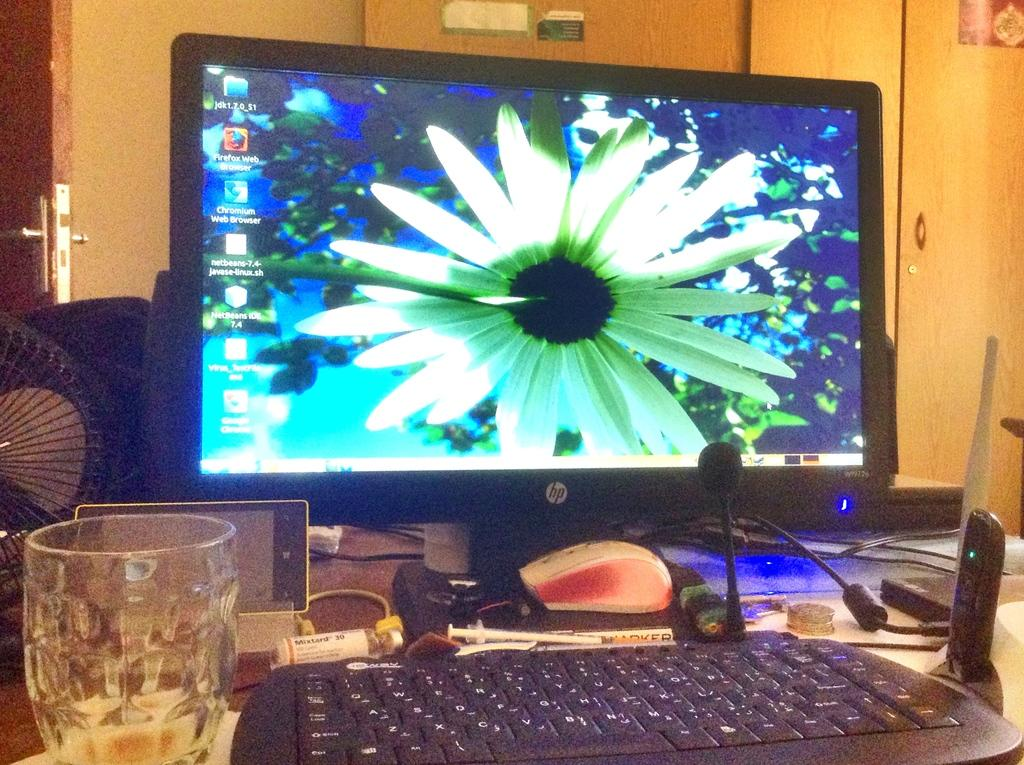What electronic device is on the table in the image? There is a computer on the table in the image. What type of container is on the table? There is a glass on the table. Can you identify any other objects in the image? Yes, there is a fan in the image. What type of gate is visible in the image? There is no gate present in the image. How much tax is being paid for the computer in the image? There is no information about taxes in the image. 